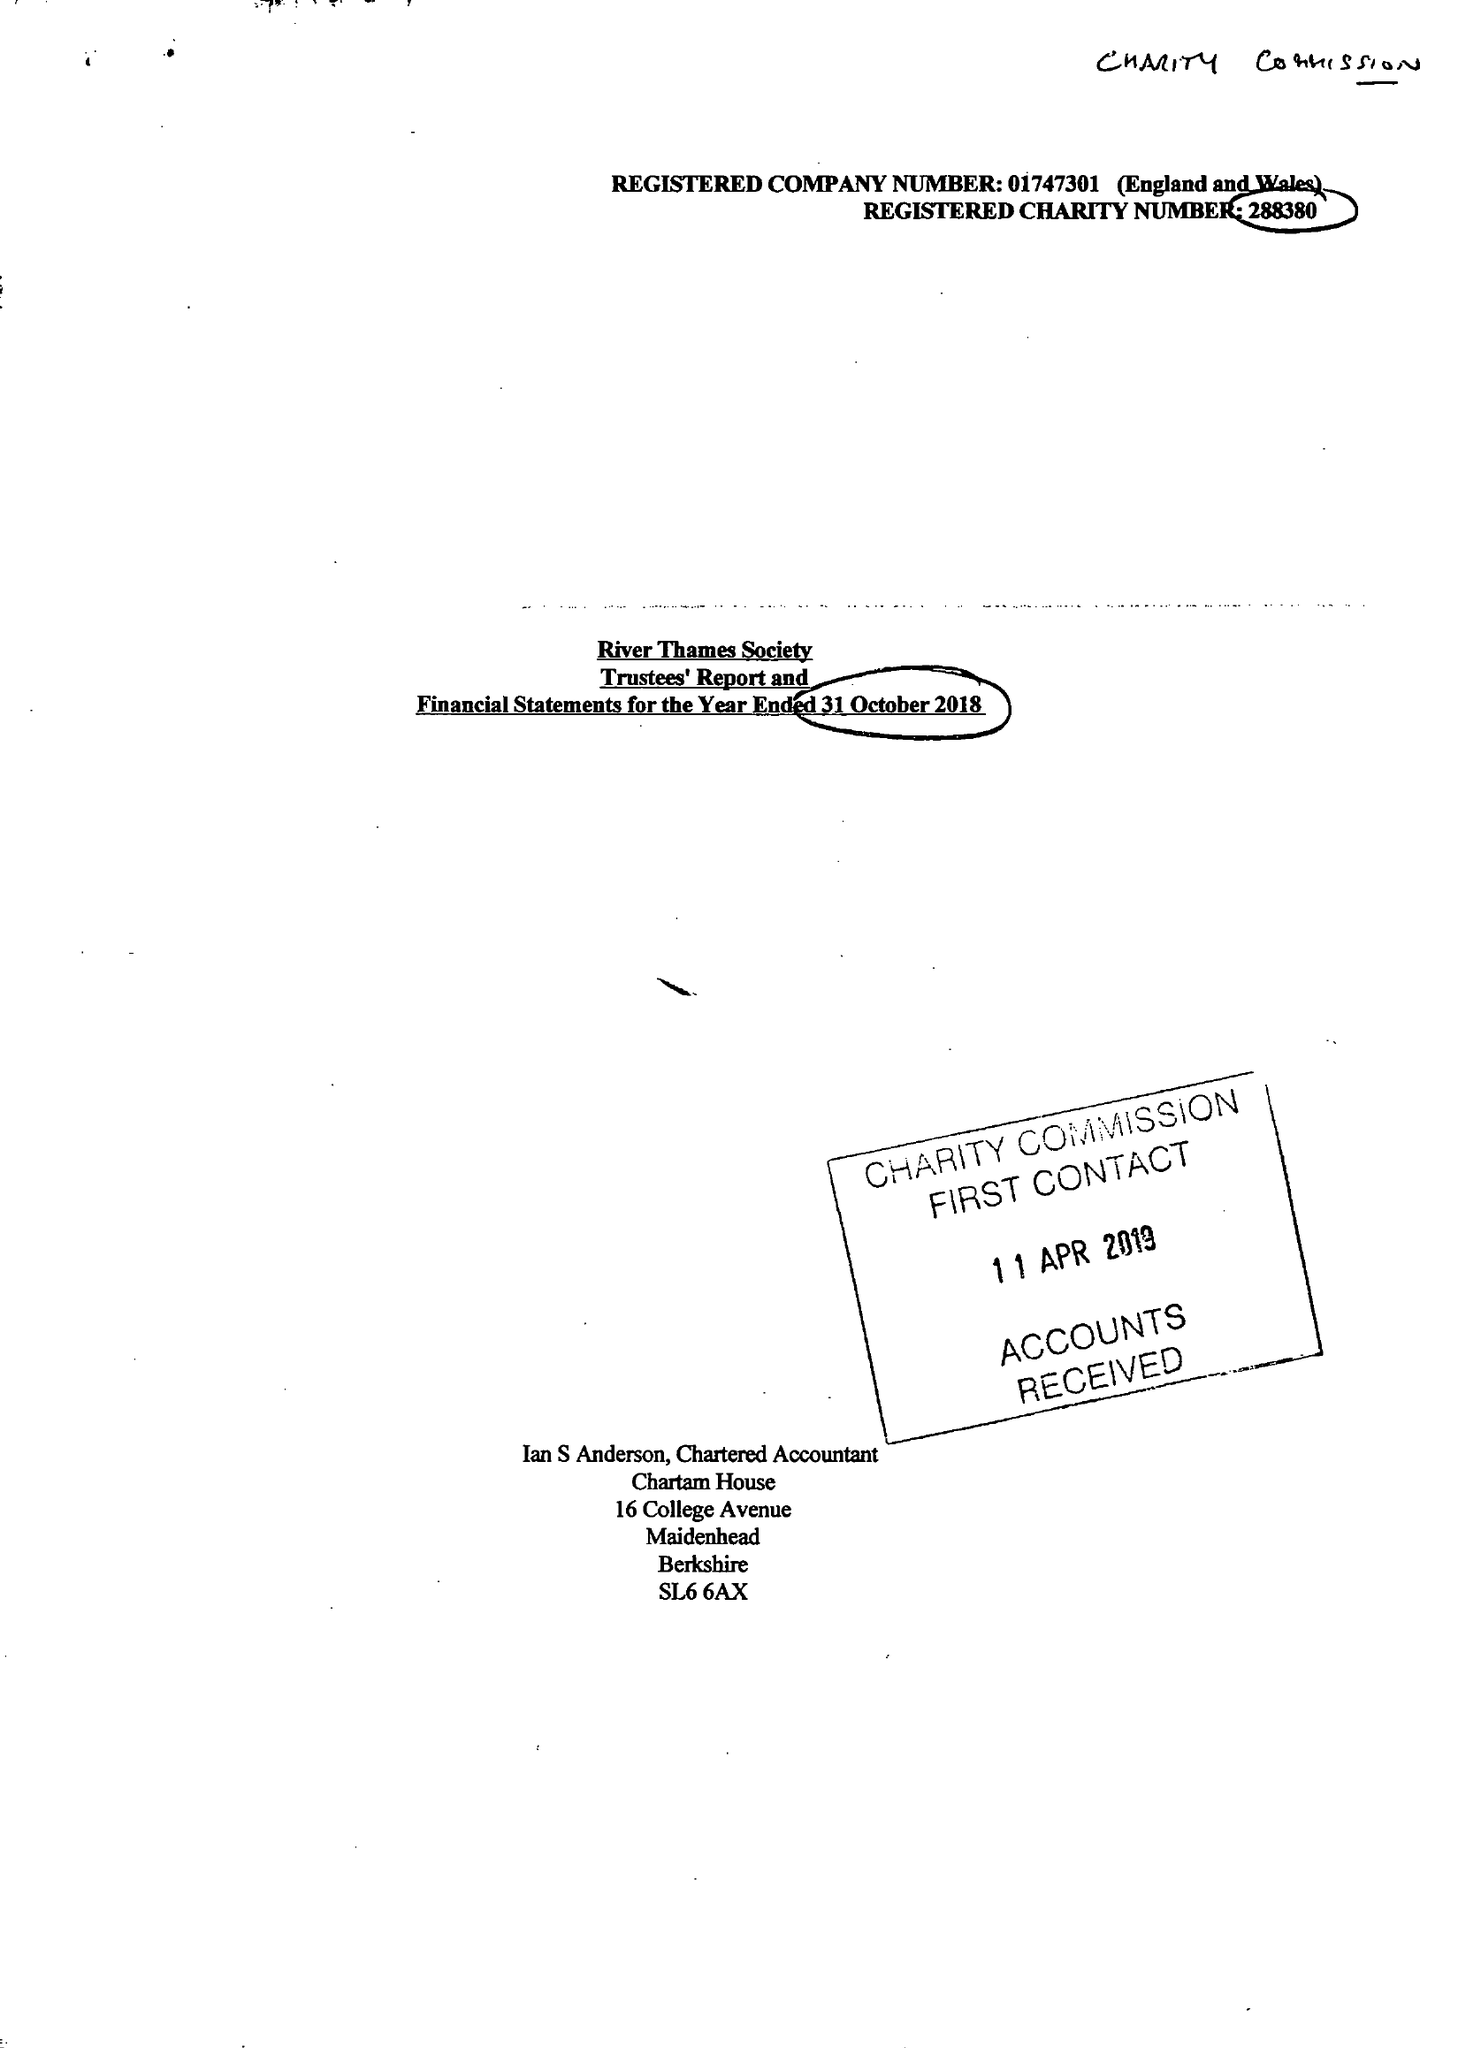What is the value for the address__street_line?
Answer the question using a single word or phrase. 28 BEAUMONT ROAD 